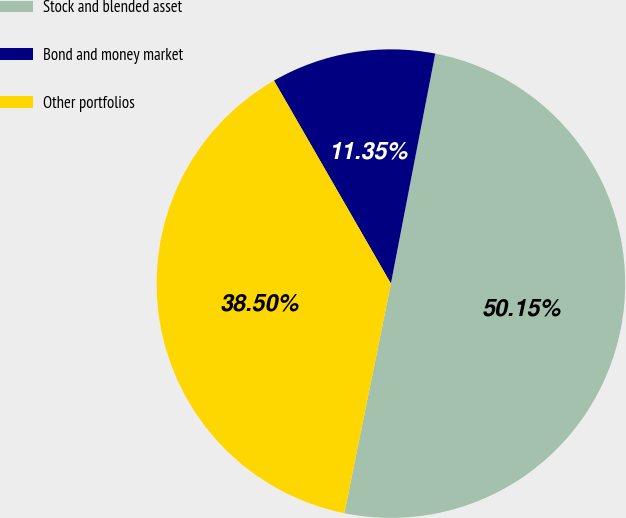Convert chart to OTSL. <chart><loc_0><loc_0><loc_500><loc_500><pie_chart><fcel>Stock and blended asset<fcel>Bond and money market<fcel>Other portfolios<nl><fcel>50.15%<fcel>11.35%<fcel>38.5%<nl></chart> 